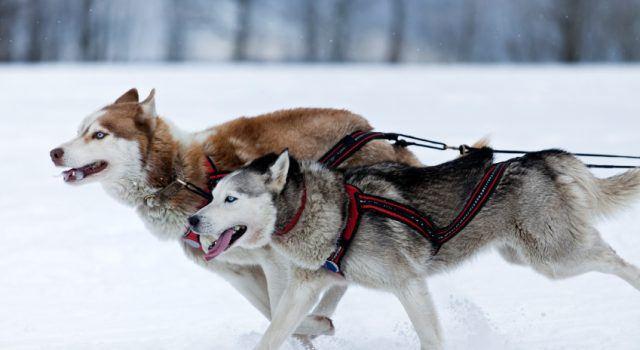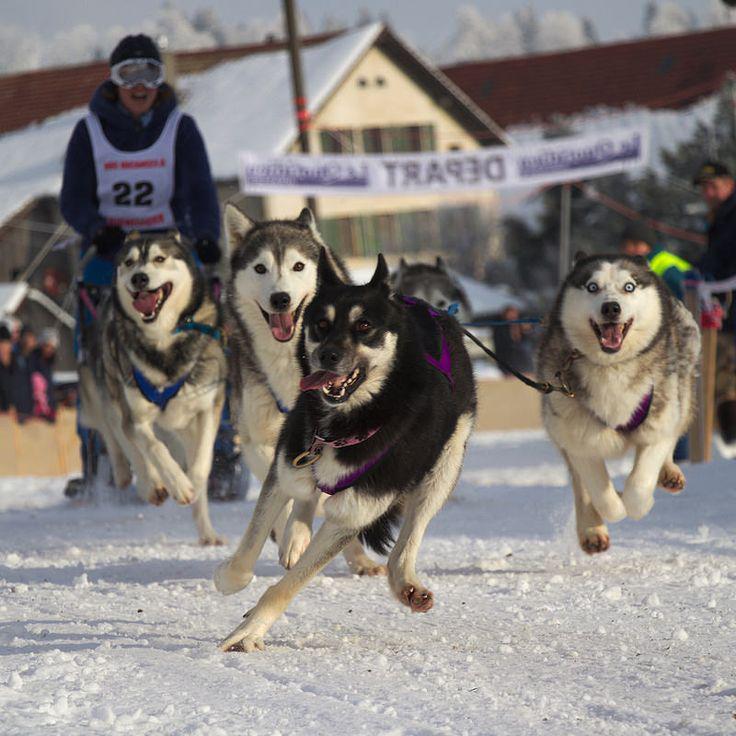The first image is the image on the left, the second image is the image on the right. Considering the images on both sides, is "Two dogs are connected to reins in the image on the left." valid? Answer yes or no. Yes. 